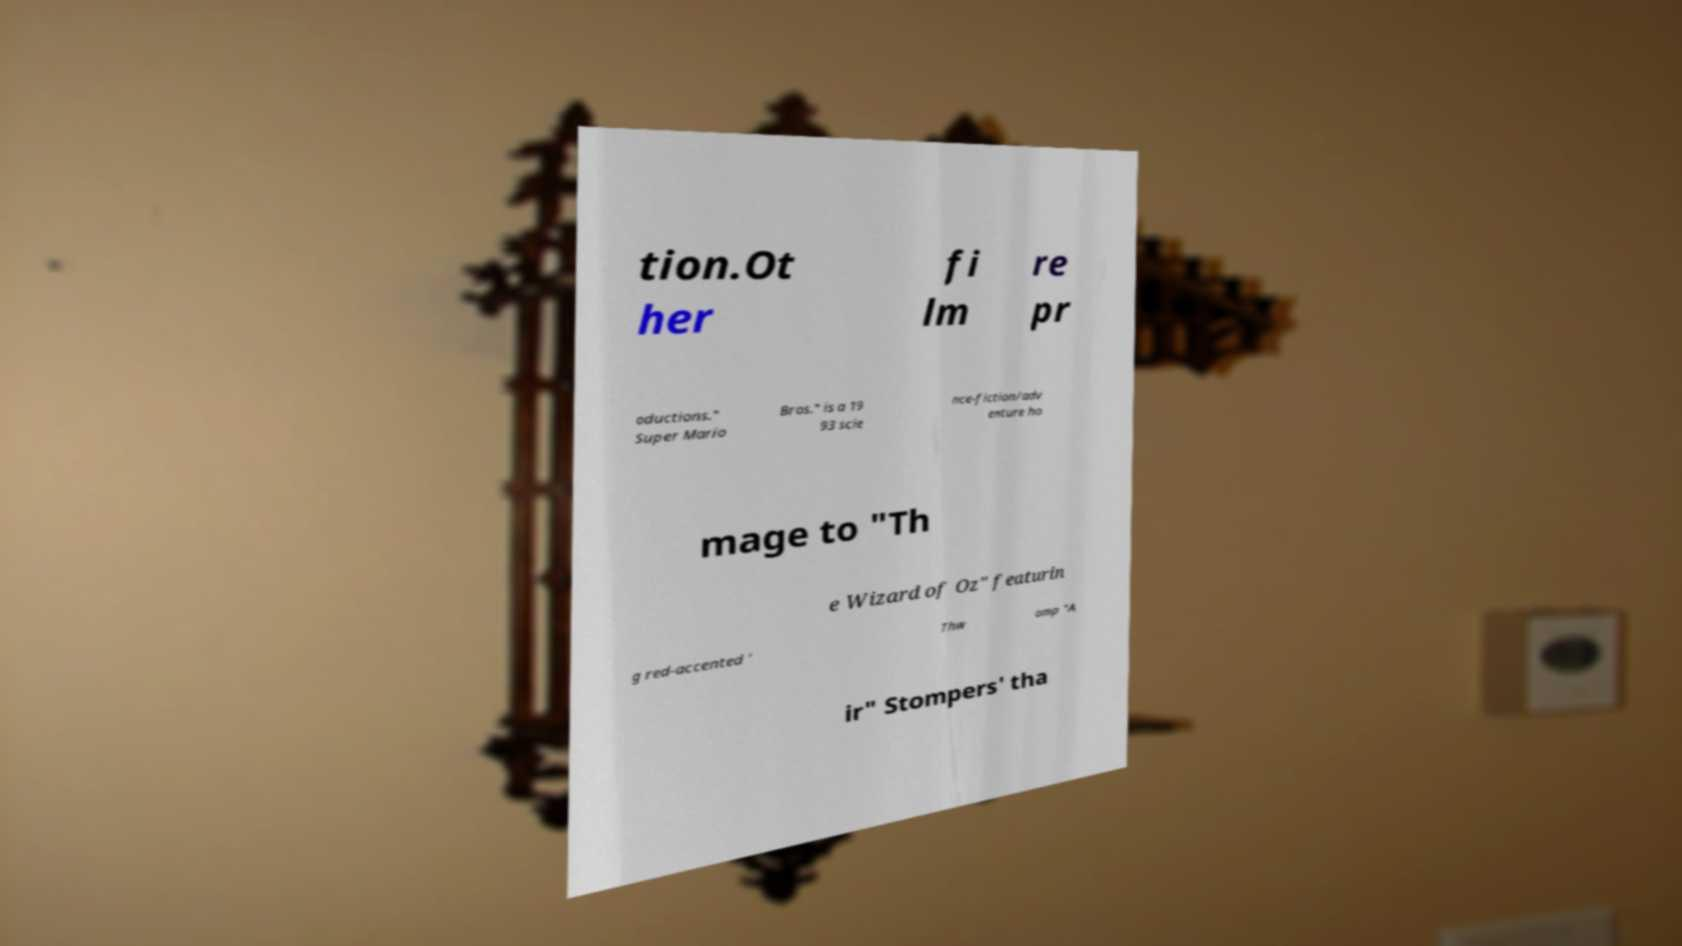Please read and relay the text visible in this image. What does it say? tion.Ot her fi lm re pr oductions." Super Mario Bros." is a 19 93 scie nce-fiction/adv enture ho mage to "Th e Wizard of Oz" featurin g red-accented ' Thw omp "A ir" Stompers' tha 